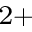Convert formula to latex. <formula><loc_0><loc_0><loc_500><loc_500>^ { 2 + }</formula> 